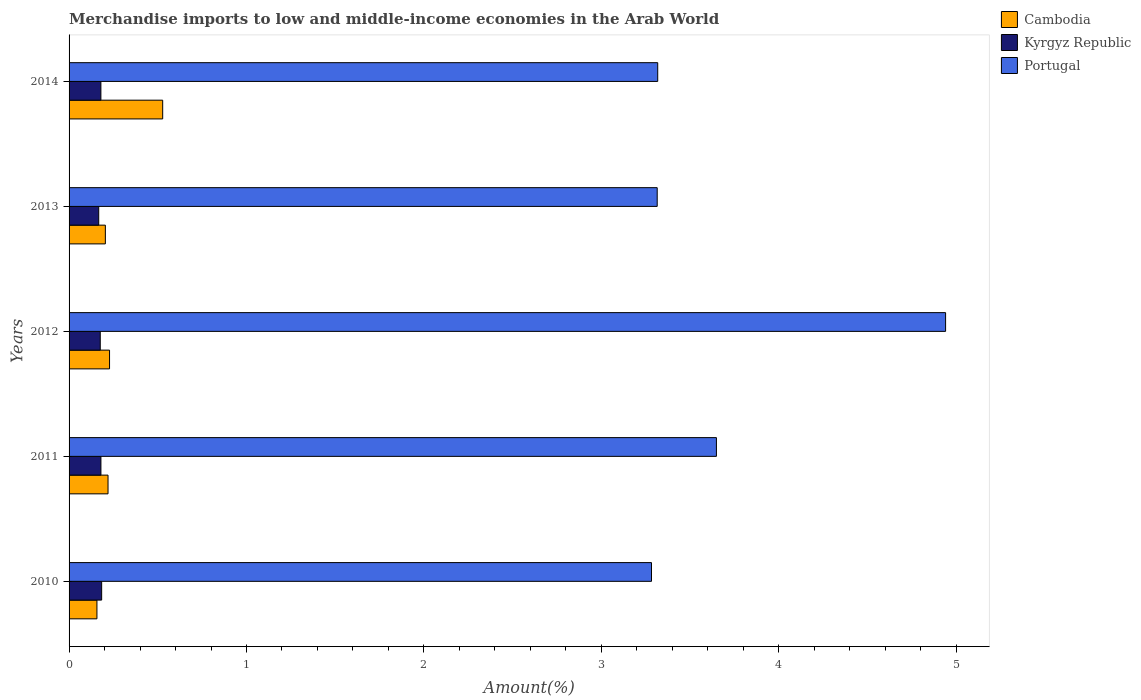How many bars are there on the 4th tick from the top?
Give a very brief answer. 3. How many bars are there on the 4th tick from the bottom?
Your answer should be very brief. 3. What is the percentage of amount earned from merchandise imports in Kyrgyz Republic in 2011?
Provide a short and direct response. 0.18. Across all years, what is the maximum percentage of amount earned from merchandise imports in Portugal?
Keep it short and to the point. 4.94. Across all years, what is the minimum percentage of amount earned from merchandise imports in Cambodia?
Offer a very short reply. 0.16. What is the total percentage of amount earned from merchandise imports in Kyrgyz Republic in the graph?
Offer a terse response. 0.89. What is the difference between the percentage of amount earned from merchandise imports in Kyrgyz Republic in 2010 and that in 2014?
Provide a short and direct response. 0. What is the difference between the percentage of amount earned from merchandise imports in Portugal in 2013 and the percentage of amount earned from merchandise imports in Cambodia in 2012?
Give a very brief answer. 3.09. What is the average percentage of amount earned from merchandise imports in Cambodia per year?
Keep it short and to the point. 0.27. In the year 2013, what is the difference between the percentage of amount earned from merchandise imports in Kyrgyz Republic and percentage of amount earned from merchandise imports in Cambodia?
Provide a succinct answer. -0.04. In how many years, is the percentage of amount earned from merchandise imports in Cambodia greater than 3.8 %?
Ensure brevity in your answer.  0. What is the ratio of the percentage of amount earned from merchandise imports in Kyrgyz Republic in 2010 to that in 2011?
Ensure brevity in your answer.  1.02. Is the difference between the percentage of amount earned from merchandise imports in Kyrgyz Republic in 2011 and 2012 greater than the difference between the percentage of amount earned from merchandise imports in Cambodia in 2011 and 2012?
Your answer should be compact. Yes. What is the difference between the highest and the second highest percentage of amount earned from merchandise imports in Portugal?
Provide a succinct answer. 1.29. What is the difference between the highest and the lowest percentage of amount earned from merchandise imports in Portugal?
Ensure brevity in your answer.  1.66. In how many years, is the percentage of amount earned from merchandise imports in Portugal greater than the average percentage of amount earned from merchandise imports in Portugal taken over all years?
Provide a short and direct response. 1. Is the sum of the percentage of amount earned from merchandise imports in Kyrgyz Republic in 2012 and 2014 greater than the maximum percentage of amount earned from merchandise imports in Portugal across all years?
Give a very brief answer. No. What does the 2nd bar from the top in 2012 represents?
Provide a short and direct response. Kyrgyz Republic. What does the 3rd bar from the bottom in 2013 represents?
Provide a short and direct response. Portugal. Is it the case that in every year, the sum of the percentage of amount earned from merchandise imports in Cambodia and percentage of amount earned from merchandise imports in Portugal is greater than the percentage of amount earned from merchandise imports in Kyrgyz Republic?
Your answer should be compact. Yes. How many bars are there?
Your answer should be very brief. 15. Are the values on the major ticks of X-axis written in scientific E-notation?
Keep it short and to the point. No. How many legend labels are there?
Offer a terse response. 3. What is the title of the graph?
Your response must be concise. Merchandise imports to low and middle-income economies in the Arab World. What is the label or title of the X-axis?
Keep it short and to the point. Amount(%). What is the label or title of the Y-axis?
Your response must be concise. Years. What is the Amount(%) in Cambodia in 2010?
Ensure brevity in your answer.  0.16. What is the Amount(%) of Kyrgyz Republic in 2010?
Offer a very short reply. 0.18. What is the Amount(%) of Portugal in 2010?
Make the answer very short. 3.28. What is the Amount(%) in Cambodia in 2011?
Make the answer very short. 0.22. What is the Amount(%) in Kyrgyz Republic in 2011?
Your answer should be compact. 0.18. What is the Amount(%) in Portugal in 2011?
Provide a short and direct response. 3.65. What is the Amount(%) in Cambodia in 2012?
Your answer should be compact. 0.23. What is the Amount(%) of Kyrgyz Republic in 2012?
Offer a terse response. 0.18. What is the Amount(%) of Portugal in 2012?
Your answer should be very brief. 4.94. What is the Amount(%) in Cambodia in 2013?
Provide a succinct answer. 0.2. What is the Amount(%) of Kyrgyz Republic in 2013?
Give a very brief answer. 0.17. What is the Amount(%) in Portugal in 2013?
Ensure brevity in your answer.  3.32. What is the Amount(%) of Cambodia in 2014?
Ensure brevity in your answer.  0.53. What is the Amount(%) in Kyrgyz Republic in 2014?
Make the answer very short. 0.18. What is the Amount(%) of Portugal in 2014?
Your response must be concise. 3.32. Across all years, what is the maximum Amount(%) of Cambodia?
Keep it short and to the point. 0.53. Across all years, what is the maximum Amount(%) in Kyrgyz Republic?
Provide a succinct answer. 0.18. Across all years, what is the maximum Amount(%) of Portugal?
Offer a very short reply. 4.94. Across all years, what is the minimum Amount(%) of Cambodia?
Provide a short and direct response. 0.16. Across all years, what is the minimum Amount(%) of Kyrgyz Republic?
Provide a short and direct response. 0.17. Across all years, what is the minimum Amount(%) of Portugal?
Keep it short and to the point. 3.28. What is the total Amount(%) in Cambodia in the graph?
Give a very brief answer. 1.34. What is the total Amount(%) of Kyrgyz Republic in the graph?
Offer a terse response. 0.89. What is the total Amount(%) in Portugal in the graph?
Provide a short and direct response. 18.51. What is the difference between the Amount(%) in Cambodia in 2010 and that in 2011?
Provide a succinct answer. -0.06. What is the difference between the Amount(%) of Kyrgyz Republic in 2010 and that in 2011?
Your answer should be very brief. 0. What is the difference between the Amount(%) of Portugal in 2010 and that in 2011?
Your answer should be very brief. -0.37. What is the difference between the Amount(%) of Cambodia in 2010 and that in 2012?
Ensure brevity in your answer.  -0.07. What is the difference between the Amount(%) in Kyrgyz Republic in 2010 and that in 2012?
Your response must be concise. 0.01. What is the difference between the Amount(%) of Portugal in 2010 and that in 2012?
Your answer should be very brief. -1.66. What is the difference between the Amount(%) in Cambodia in 2010 and that in 2013?
Make the answer very short. -0.05. What is the difference between the Amount(%) of Kyrgyz Republic in 2010 and that in 2013?
Provide a short and direct response. 0.02. What is the difference between the Amount(%) of Portugal in 2010 and that in 2013?
Provide a succinct answer. -0.03. What is the difference between the Amount(%) in Cambodia in 2010 and that in 2014?
Make the answer very short. -0.37. What is the difference between the Amount(%) of Kyrgyz Republic in 2010 and that in 2014?
Offer a terse response. 0. What is the difference between the Amount(%) of Portugal in 2010 and that in 2014?
Make the answer very short. -0.04. What is the difference between the Amount(%) of Cambodia in 2011 and that in 2012?
Ensure brevity in your answer.  -0.01. What is the difference between the Amount(%) in Kyrgyz Republic in 2011 and that in 2012?
Offer a very short reply. 0. What is the difference between the Amount(%) of Portugal in 2011 and that in 2012?
Provide a succinct answer. -1.29. What is the difference between the Amount(%) in Cambodia in 2011 and that in 2013?
Ensure brevity in your answer.  0.01. What is the difference between the Amount(%) of Kyrgyz Republic in 2011 and that in 2013?
Your response must be concise. 0.01. What is the difference between the Amount(%) in Portugal in 2011 and that in 2013?
Give a very brief answer. 0.33. What is the difference between the Amount(%) in Cambodia in 2011 and that in 2014?
Keep it short and to the point. -0.31. What is the difference between the Amount(%) of Portugal in 2011 and that in 2014?
Provide a short and direct response. 0.33. What is the difference between the Amount(%) in Cambodia in 2012 and that in 2013?
Keep it short and to the point. 0.02. What is the difference between the Amount(%) of Kyrgyz Republic in 2012 and that in 2013?
Give a very brief answer. 0.01. What is the difference between the Amount(%) in Portugal in 2012 and that in 2013?
Your answer should be very brief. 1.63. What is the difference between the Amount(%) of Cambodia in 2012 and that in 2014?
Your answer should be compact. -0.3. What is the difference between the Amount(%) of Kyrgyz Republic in 2012 and that in 2014?
Your response must be concise. -0. What is the difference between the Amount(%) in Portugal in 2012 and that in 2014?
Offer a very short reply. 1.62. What is the difference between the Amount(%) in Cambodia in 2013 and that in 2014?
Give a very brief answer. -0.32. What is the difference between the Amount(%) in Kyrgyz Republic in 2013 and that in 2014?
Make the answer very short. -0.01. What is the difference between the Amount(%) in Portugal in 2013 and that in 2014?
Make the answer very short. -0. What is the difference between the Amount(%) in Cambodia in 2010 and the Amount(%) in Kyrgyz Republic in 2011?
Offer a very short reply. -0.02. What is the difference between the Amount(%) in Cambodia in 2010 and the Amount(%) in Portugal in 2011?
Offer a terse response. -3.49. What is the difference between the Amount(%) in Kyrgyz Republic in 2010 and the Amount(%) in Portugal in 2011?
Your response must be concise. -3.47. What is the difference between the Amount(%) of Cambodia in 2010 and the Amount(%) of Kyrgyz Republic in 2012?
Your answer should be very brief. -0.02. What is the difference between the Amount(%) of Cambodia in 2010 and the Amount(%) of Portugal in 2012?
Your answer should be very brief. -4.78. What is the difference between the Amount(%) of Kyrgyz Republic in 2010 and the Amount(%) of Portugal in 2012?
Make the answer very short. -4.76. What is the difference between the Amount(%) in Cambodia in 2010 and the Amount(%) in Kyrgyz Republic in 2013?
Your answer should be very brief. -0.01. What is the difference between the Amount(%) of Cambodia in 2010 and the Amount(%) of Portugal in 2013?
Offer a terse response. -3.16. What is the difference between the Amount(%) in Kyrgyz Republic in 2010 and the Amount(%) in Portugal in 2013?
Offer a very short reply. -3.13. What is the difference between the Amount(%) of Cambodia in 2010 and the Amount(%) of Kyrgyz Republic in 2014?
Your response must be concise. -0.02. What is the difference between the Amount(%) of Cambodia in 2010 and the Amount(%) of Portugal in 2014?
Provide a succinct answer. -3.16. What is the difference between the Amount(%) in Kyrgyz Republic in 2010 and the Amount(%) in Portugal in 2014?
Keep it short and to the point. -3.13. What is the difference between the Amount(%) of Cambodia in 2011 and the Amount(%) of Kyrgyz Republic in 2012?
Your answer should be very brief. 0.04. What is the difference between the Amount(%) in Cambodia in 2011 and the Amount(%) in Portugal in 2012?
Provide a short and direct response. -4.72. What is the difference between the Amount(%) of Kyrgyz Republic in 2011 and the Amount(%) of Portugal in 2012?
Ensure brevity in your answer.  -4.76. What is the difference between the Amount(%) in Cambodia in 2011 and the Amount(%) in Kyrgyz Republic in 2013?
Your answer should be compact. 0.05. What is the difference between the Amount(%) in Cambodia in 2011 and the Amount(%) in Portugal in 2013?
Your response must be concise. -3.1. What is the difference between the Amount(%) in Kyrgyz Republic in 2011 and the Amount(%) in Portugal in 2013?
Your answer should be very brief. -3.14. What is the difference between the Amount(%) in Cambodia in 2011 and the Amount(%) in Kyrgyz Republic in 2014?
Your answer should be compact. 0.04. What is the difference between the Amount(%) in Cambodia in 2011 and the Amount(%) in Portugal in 2014?
Offer a very short reply. -3.1. What is the difference between the Amount(%) of Kyrgyz Republic in 2011 and the Amount(%) of Portugal in 2014?
Provide a short and direct response. -3.14. What is the difference between the Amount(%) of Cambodia in 2012 and the Amount(%) of Kyrgyz Republic in 2013?
Your response must be concise. 0.06. What is the difference between the Amount(%) of Cambodia in 2012 and the Amount(%) of Portugal in 2013?
Give a very brief answer. -3.09. What is the difference between the Amount(%) in Kyrgyz Republic in 2012 and the Amount(%) in Portugal in 2013?
Provide a short and direct response. -3.14. What is the difference between the Amount(%) in Cambodia in 2012 and the Amount(%) in Kyrgyz Republic in 2014?
Your answer should be compact. 0.05. What is the difference between the Amount(%) of Cambodia in 2012 and the Amount(%) of Portugal in 2014?
Your answer should be very brief. -3.09. What is the difference between the Amount(%) of Kyrgyz Republic in 2012 and the Amount(%) of Portugal in 2014?
Keep it short and to the point. -3.14. What is the difference between the Amount(%) of Cambodia in 2013 and the Amount(%) of Kyrgyz Republic in 2014?
Offer a very short reply. 0.03. What is the difference between the Amount(%) of Cambodia in 2013 and the Amount(%) of Portugal in 2014?
Give a very brief answer. -3.11. What is the difference between the Amount(%) of Kyrgyz Republic in 2013 and the Amount(%) of Portugal in 2014?
Offer a terse response. -3.15. What is the average Amount(%) of Cambodia per year?
Offer a terse response. 0.27. What is the average Amount(%) of Kyrgyz Republic per year?
Keep it short and to the point. 0.18. What is the average Amount(%) in Portugal per year?
Make the answer very short. 3.7. In the year 2010, what is the difference between the Amount(%) of Cambodia and Amount(%) of Kyrgyz Republic?
Offer a terse response. -0.03. In the year 2010, what is the difference between the Amount(%) of Cambodia and Amount(%) of Portugal?
Your answer should be very brief. -3.13. In the year 2010, what is the difference between the Amount(%) of Kyrgyz Republic and Amount(%) of Portugal?
Your answer should be very brief. -3.1. In the year 2011, what is the difference between the Amount(%) of Cambodia and Amount(%) of Kyrgyz Republic?
Offer a very short reply. 0.04. In the year 2011, what is the difference between the Amount(%) in Cambodia and Amount(%) in Portugal?
Give a very brief answer. -3.43. In the year 2011, what is the difference between the Amount(%) in Kyrgyz Republic and Amount(%) in Portugal?
Your answer should be compact. -3.47. In the year 2012, what is the difference between the Amount(%) in Cambodia and Amount(%) in Kyrgyz Republic?
Give a very brief answer. 0.05. In the year 2012, what is the difference between the Amount(%) of Cambodia and Amount(%) of Portugal?
Give a very brief answer. -4.71. In the year 2012, what is the difference between the Amount(%) in Kyrgyz Republic and Amount(%) in Portugal?
Offer a very short reply. -4.76. In the year 2013, what is the difference between the Amount(%) of Cambodia and Amount(%) of Kyrgyz Republic?
Keep it short and to the point. 0.04. In the year 2013, what is the difference between the Amount(%) of Cambodia and Amount(%) of Portugal?
Your answer should be compact. -3.11. In the year 2013, what is the difference between the Amount(%) of Kyrgyz Republic and Amount(%) of Portugal?
Your answer should be very brief. -3.15. In the year 2014, what is the difference between the Amount(%) in Cambodia and Amount(%) in Kyrgyz Republic?
Ensure brevity in your answer.  0.35. In the year 2014, what is the difference between the Amount(%) of Cambodia and Amount(%) of Portugal?
Your answer should be compact. -2.79. In the year 2014, what is the difference between the Amount(%) in Kyrgyz Republic and Amount(%) in Portugal?
Make the answer very short. -3.14. What is the ratio of the Amount(%) of Cambodia in 2010 to that in 2011?
Offer a very short reply. 0.72. What is the ratio of the Amount(%) in Kyrgyz Republic in 2010 to that in 2011?
Give a very brief answer. 1.02. What is the ratio of the Amount(%) in Portugal in 2010 to that in 2011?
Your answer should be very brief. 0.9. What is the ratio of the Amount(%) of Cambodia in 2010 to that in 2012?
Your answer should be compact. 0.69. What is the ratio of the Amount(%) of Kyrgyz Republic in 2010 to that in 2012?
Provide a succinct answer. 1.04. What is the ratio of the Amount(%) in Portugal in 2010 to that in 2012?
Keep it short and to the point. 0.66. What is the ratio of the Amount(%) in Cambodia in 2010 to that in 2013?
Give a very brief answer. 0.77. What is the ratio of the Amount(%) in Kyrgyz Republic in 2010 to that in 2013?
Offer a terse response. 1.1. What is the ratio of the Amount(%) of Portugal in 2010 to that in 2013?
Offer a very short reply. 0.99. What is the ratio of the Amount(%) in Cambodia in 2010 to that in 2014?
Make the answer very short. 0.3. What is the ratio of the Amount(%) of Kyrgyz Republic in 2010 to that in 2014?
Offer a very short reply. 1.02. What is the ratio of the Amount(%) of Portugal in 2010 to that in 2014?
Provide a short and direct response. 0.99. What is the ratio of the Amount(%) of Cambodia in 2011 to that in 2012?
Make the answer very short. 0.96. What is the ratio of the Amount(%) in Kyrgyz Republic in 2011 to that in 2012?
Offer a terse response. 1.02. What is the ratio of the Amount(%) in Portugal in 2011 to that in 2012?
Provide a succinct answer. 0.74. What is the ratio of the Amount(%) of Cambodia in 2011 to that in 2013?
Your answer should be very brief. 1.07. What is the ratio of the Amount(%) of Kyrgyz Republic in 2011 to that in 2013?
Offer a terse response. 1.07. What is the ratio of the Amount(%) of Portugal in 2011 to that in 2013?
Ensure brevity in your answer.  1.1. What is the ratio of the Amount(%) in Cambodia in 2011 to that in 2014?
Your response must be concise. 0.42. What is the ratio of the Amount(%) of Portugal in 2011 to that in 2014?
Your answer should be compact. 1.1. What is the ratio of the Amount(%) of Cambodia in 2012 to that in 2013?
Offer a terse response. 1.12. What is the ratio of the Amount(%) in Kyrgyz Republic in 2012 to that in 2013?
Offer a terse response. 1.05. What is the ratio of the Amount(%) of Portugal in 2012 to that in 2013?
Give a very brief answer. 1.49. What is the ratio of the Amount(%) in Cambodia in 2012 to that in 2014?
Your response must be concise. 0.43. What is the ratio of the Amount(%) in Kyrgyz Republic in 2012 to that in 2014?
Provide a succinct answer. 0.98. What is the ratio of the Amount(%) in Portugal in 2012 to that in 2014?
Provide a short and direct response. 1.49. What is the ratio of the Amount(%) of Cambodia in 2013 to that in 2014?
Your response must be concise. 0.39. What is the ratio of the Amount(%) in Kyrgyz Republic in 2013 to that in 2014?
Your response must be concise. 0.93. What is the ratio of the Amount(%) of Portugal in 2013 to that in 2014?
Provide a short and direct response. 1. What is the difference between the highest and the second highest Amount(%) of Cambodia?
Provide a succinct answer. 0.3. What is the difference between the highest and the second highest Amount(%) of Kyrgyz Republic?
Your answer should be very brief. 0. What is the difference between the highest and the second highest Amount(%) of Portugal?
Your response must be concise. 1.29. What is the difference between the highest and the lowest Amount(%) in Cambodia?
Offer a terse response. 0.37. What is the difference between the highest and the lowest Amount(%) in Kyrgyz Republic?
Your response must be concise. 0.02. What is the difference between the highest and the lowest Amount(%) in Portugal?
Offer a terse response. 1.66. 